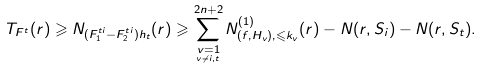<formula> <loc_0><loc_0><loc_500><loc_500>T _ { F ^ { t } } ( r ) & \geqslant N _ { ( F _ { 1 } ^ { t i } - F _ { 2 } ^ { t i } ) h _ { t } } ( r ) \geqslant \sum _ { \underset { v \ne i , t } { v = 1 } } ^ { 2 n + 2 } N ^ { ( 1 ) } _ { ( f , H _ { v } ) , \leqslant k _ { v } } ( r ) - N ( r , S _ { i } ) - N ( r , S _ { t } ) .</formula> 